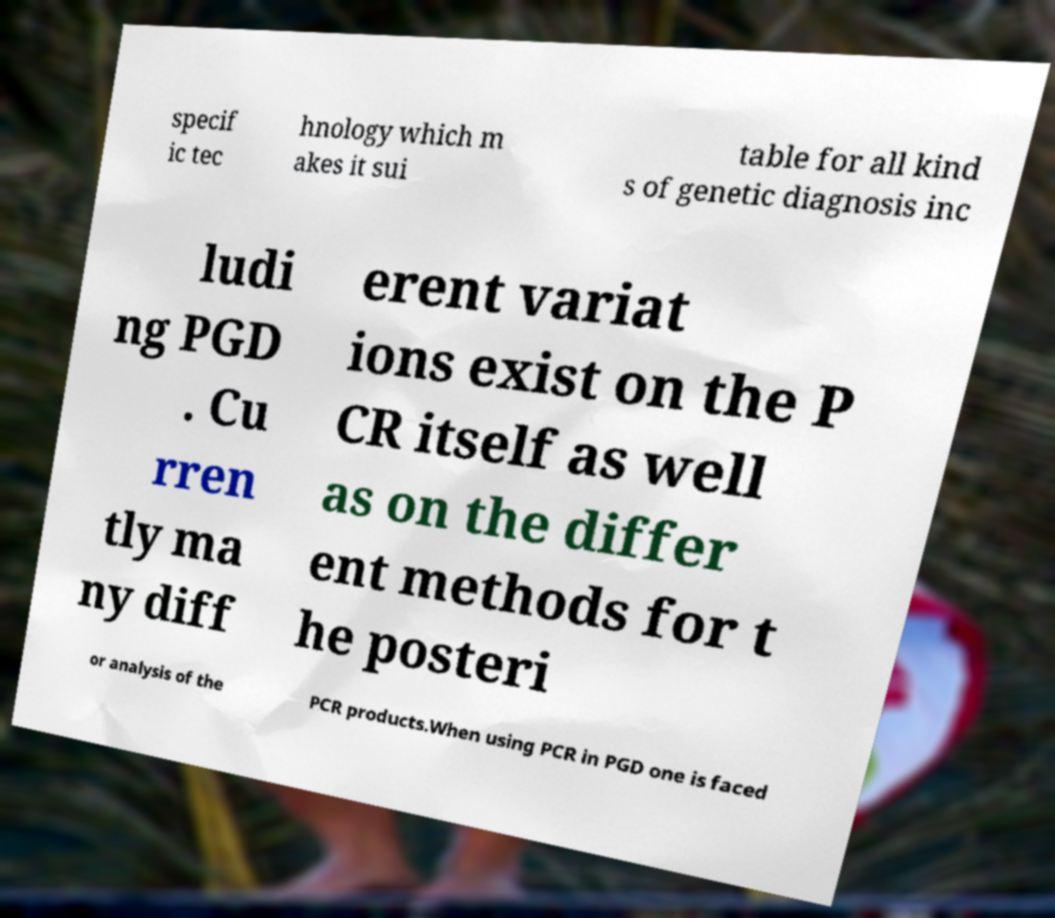Can you read and provide the text displayed in the image?This photo seems to have some interesting text. Can you extract and type it out for me? specif ic tec hnology which m akes it sui table for all kind s of genetic diagnosis inc ludi ng PGD . Cu rren tly ma ny diff erent variat ions exist on the P CR itself as well as on the differ ent methods for t he posteri or analysis of the PCR products.When using PCR in PGD one is faced 